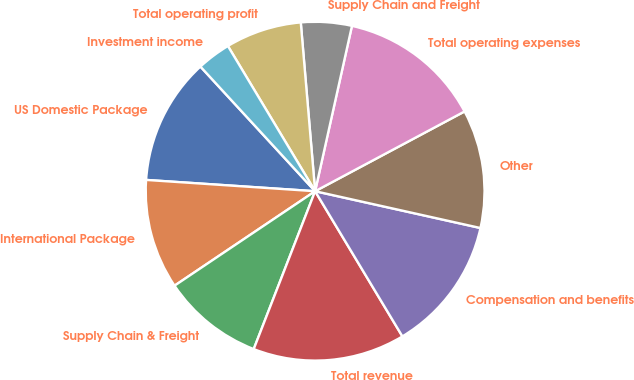Convert chart. <chart><loc_0><loc_0><loc_500><loc_500><pie_chart><fcel>US Domestic Package<fcel>International Package<fcel>Supply Chain & Freight<fcel>Total revenue<fcel>Compensation and benefits<fcel>Other<fcel>Total operating expenses<fcel>Supply Chain and Freight<fcel>Total operating profit<fcel>Investment income<nl><fcel>12.1%<fcel>10.48%<fcel>9.68%<fcel>14.52%<fcel>12.9%<fcel>11.29%<fcel>13.71%<fcel>4.84%<fcel>7.26%<fcel>3.23%<nl></chart> 